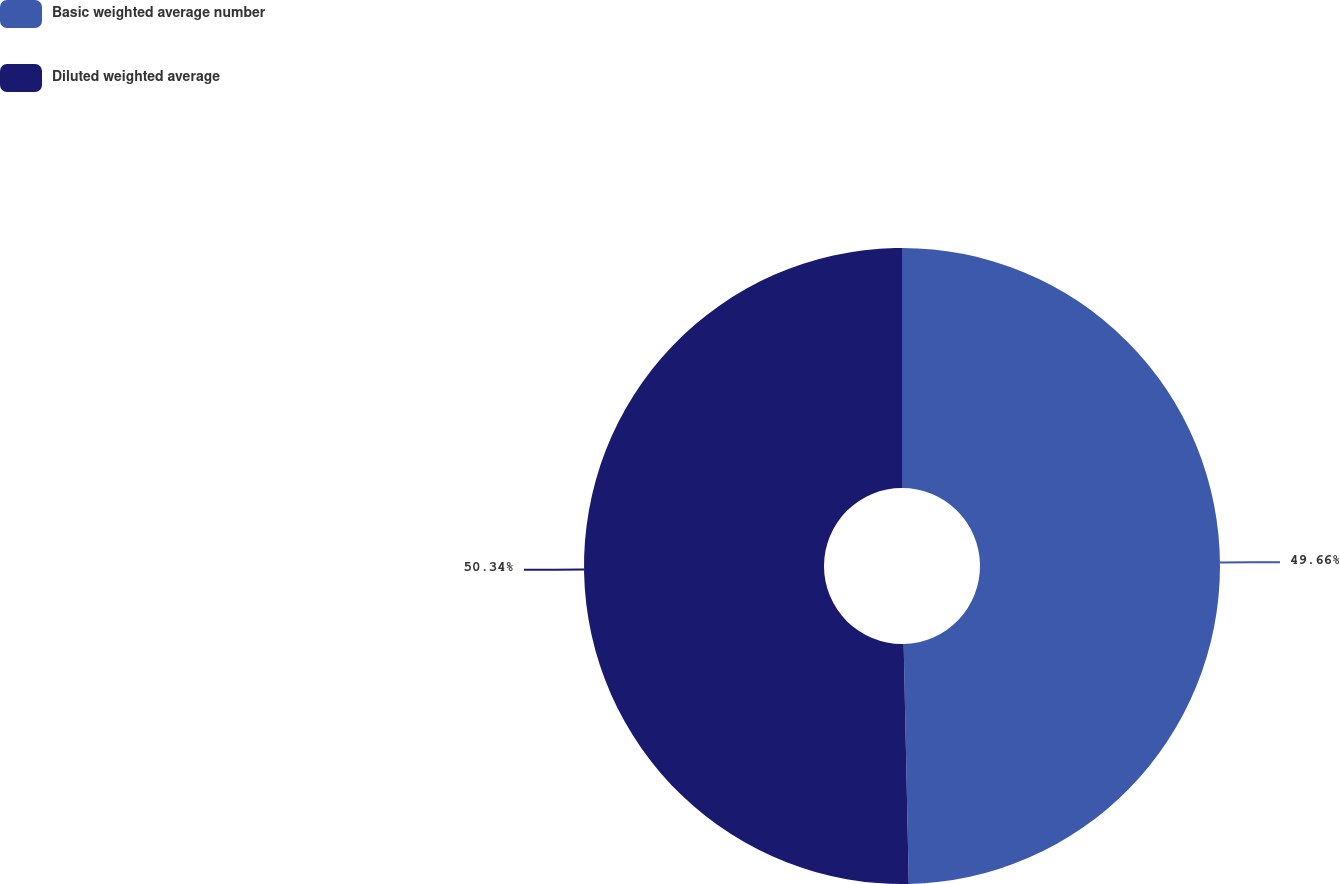Convert chart to OTSL. <chart><loc_0><loc_0><loc_500><loc_500><pie_chart><fcel>Basic weighted average number<fcel>Diluted weighted average<nl><fcel>49.66%<fcel>50.34%<nl></chart> 